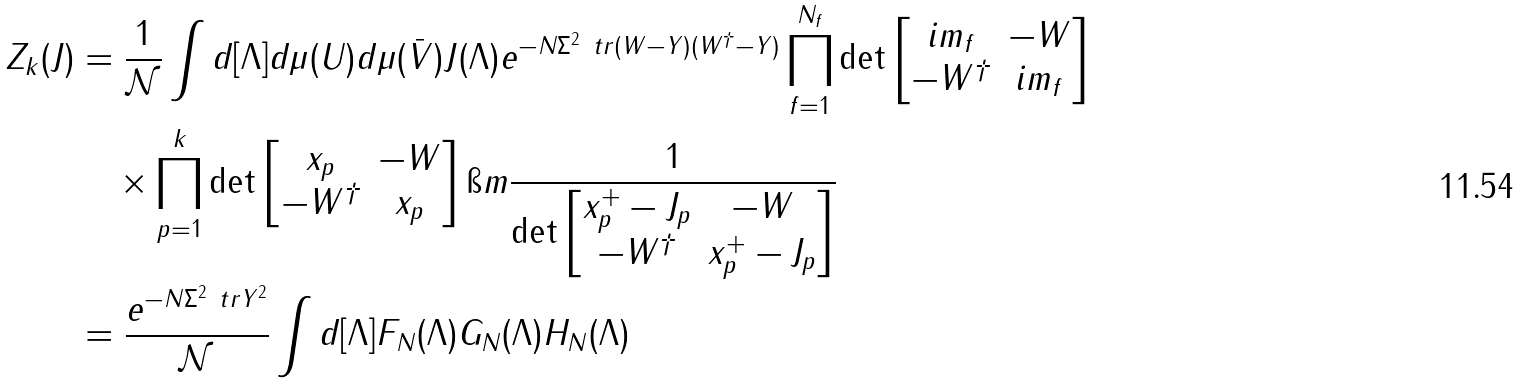<formula> <loc_0><loc_0><loc_500><loc_500>Z _ { k } ( J ) & = \frac { 1 } { \mathcal { N } } \int d [ \Lambda ] d \mu ( U ) d \mu ( \bar { V } ) J ( \Lambda ) e ^ { - N \Sigma ^ { 2 } \ t r ( W - Y ) ( W ^ { \dagger } - Y ) } \prod _ { f = 1 } ^ { N _ { f } } \det \begin{bmatrix} i m _ { f } & - W \\ - W ^ { \dagger } & i m _ { f } \end{bmatrix} \\ & \quad \times \prod _ { p = 1 } ^ { k } \det \begin{bmatrix} x _ { p } & - W \\ - W ^ { \dagger } & x _ { p } \end{bmatrix} \i m \frac { 1 } { \det \begin{bmatrix} x _ { p } ^ { + } - J _ { p } & - W \\ - W ^ { \dagger } & x _ { p } ^ { + } - J _ { p } \end{bmatrix} } \\ & = \frac { e ^ { - N \Sigma ^ { 2 } \ t r Y ^ { 2 } } } { \mathcal { N } } \int d [ \Lambda ] F _ { N } ( \Lambda ) G _ { N } ( \Lambda ) H _ { N } ( \Lambda )</formula> 